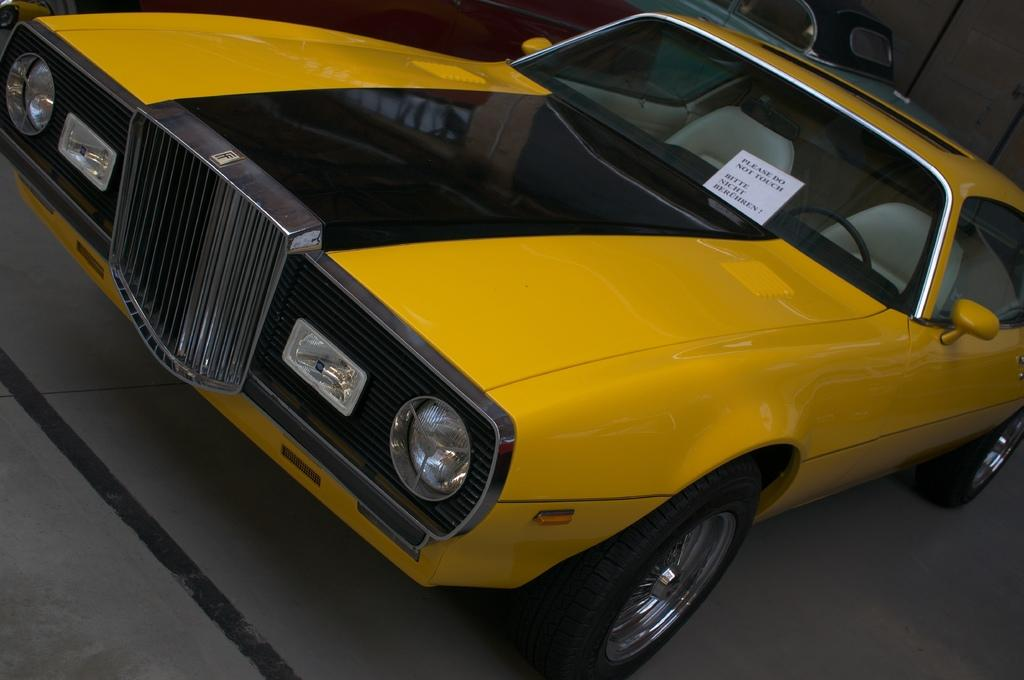What type of object is the main subject of the image? There is a vehicle in the image. What colors can be seen on the vehicle? The vehicle has a yellow and black color combination. Where is the vehicle located in the image? The vehicle is on the floor. Can you describe the background of the image? There is another vehicle and a wall in the background of the image. What type of rat can be seen running on the tracks in the downtown area in the image? There is no rat or downtown area present in the image; it features a vehicle on the floor with a yellow and black color combination. 